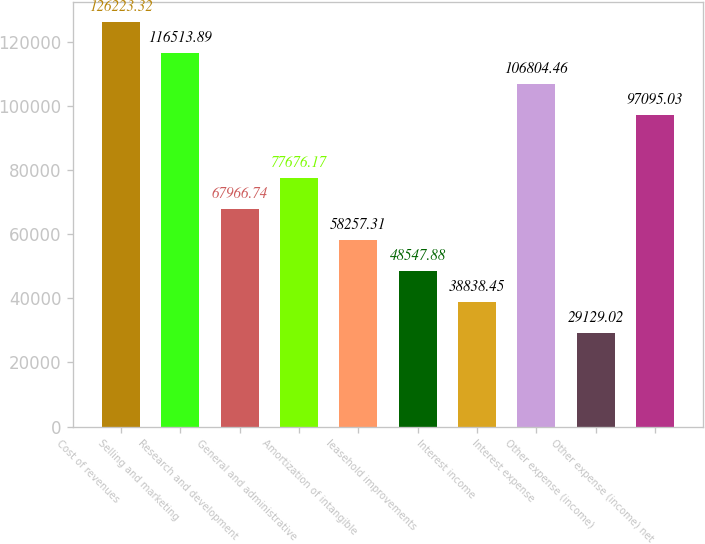<chart> <loc_0><loc_0><loc_500><loc_500><bar_chart><fcel>Cost of revenues<fcel>Selling and marketing<fcel>Research and development<fcel>General and administrative<fcel>Amortization of intangible<fcel>leasehold improvements<fcel>Interest income<fcel>Interest expense<fcel>Other expense (income)<fcel>Other expense (income) net<nl><fcel>126223<fcel>116514<fcel>67966.7<fcel>77676.2<fcel>58257.3<fcel>48547.9<fcel>38838.4<fcel>106804<fcel>29129<fcel>97095<nl></chart> 